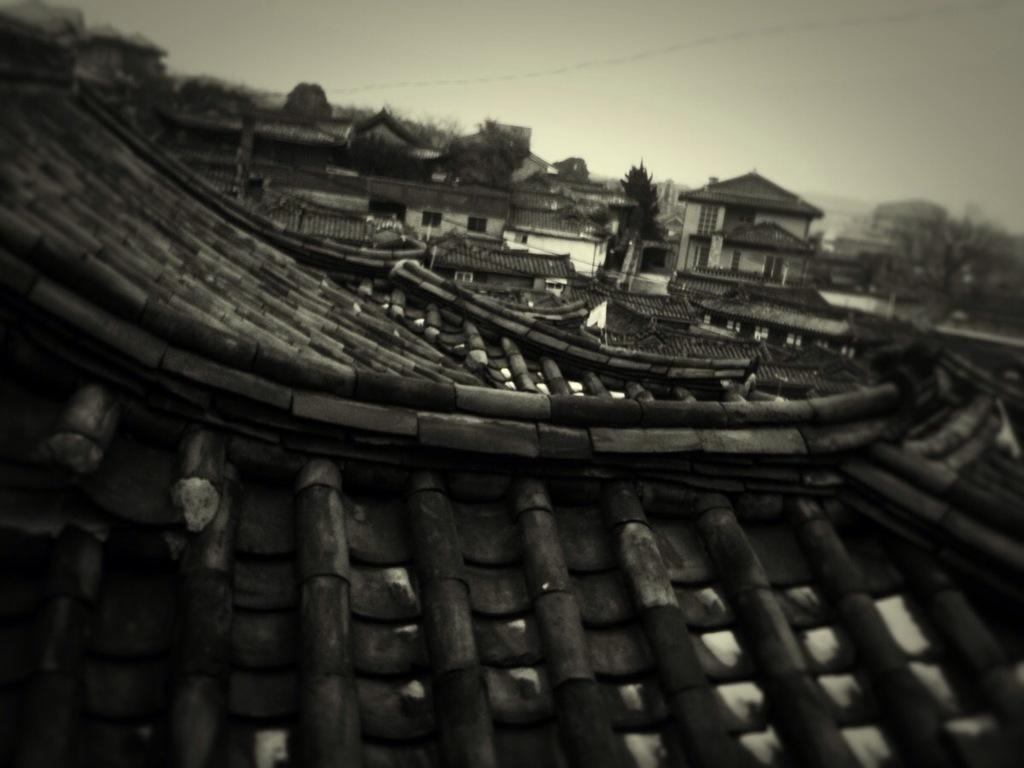What part of a house can be seen in the image? The roof of a house is visible in the image. What other structures are present in the image? There are buildings in the image. What type of vegetation is visible in the image? There are trees in the image. What is visible in the background of the image? The sky is visible in the image. How does the harmony fly in the image? There is no harmony or flying object present in the image. 